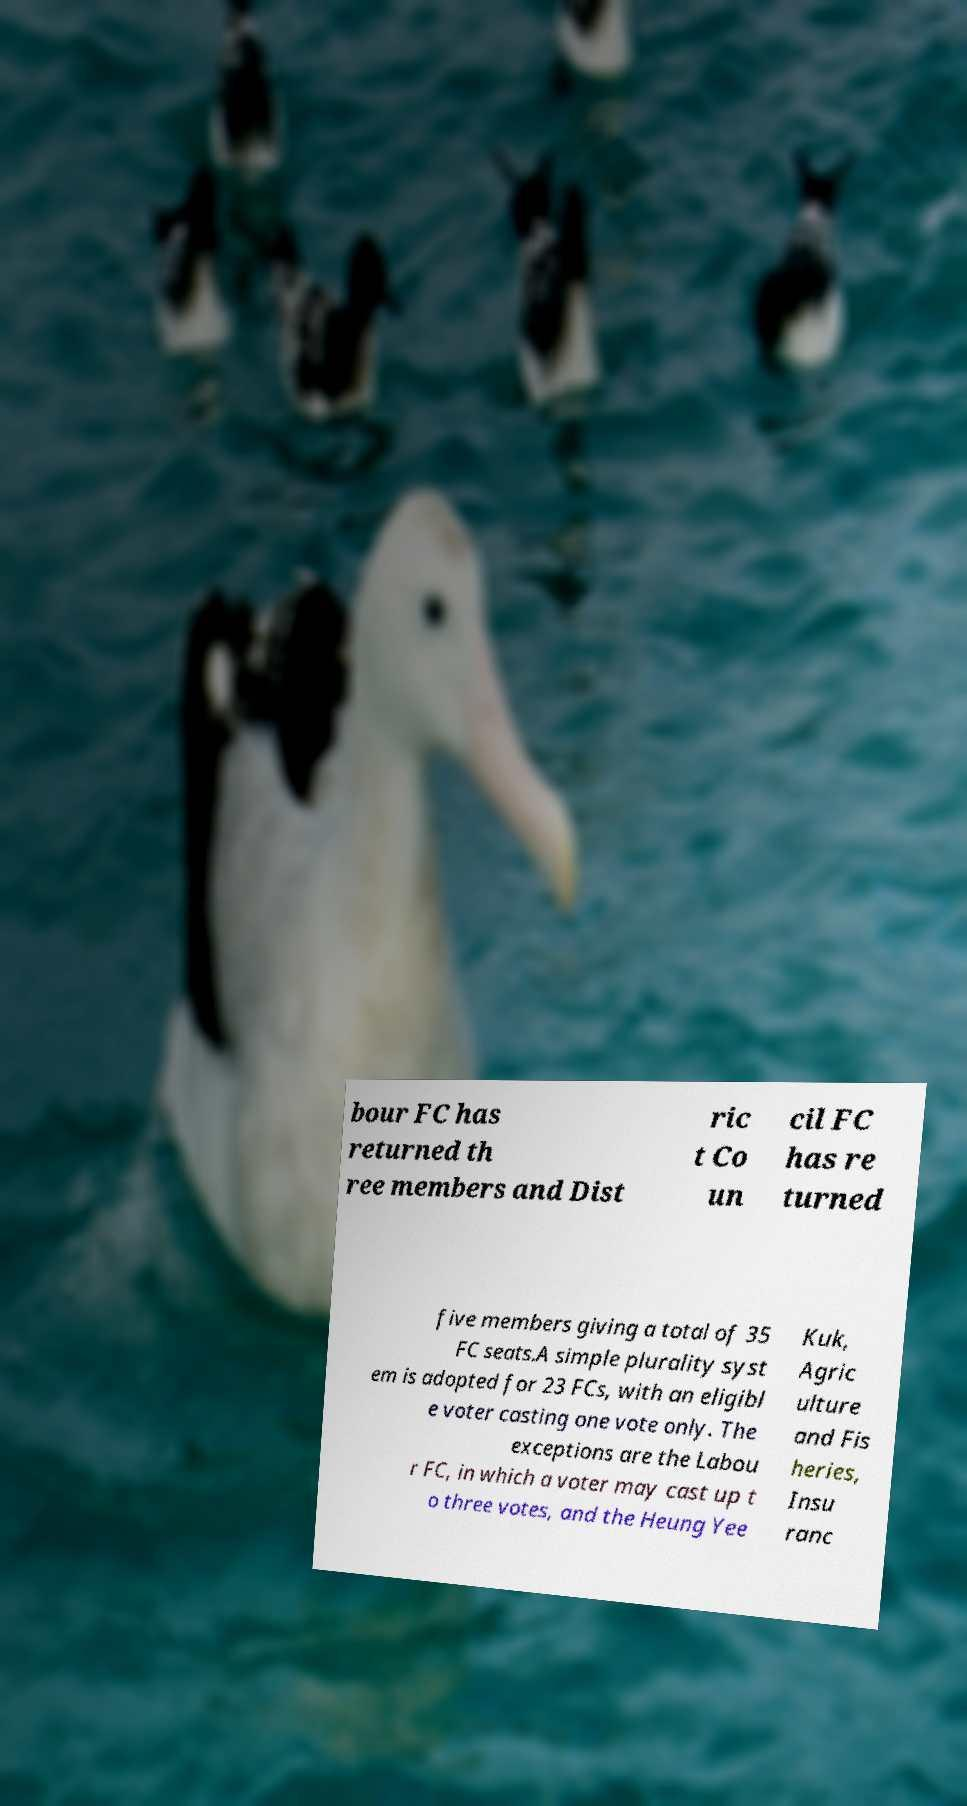Please read and relay the text visible in this image. What does it say? bour FC has returned th ree members and Dist ric t Co un cil FC has re turned five members giving a total of 35 FC seats.A simple plurality syst em is adopted for 23 FCs, with an eligibl e voter casting one vote only. The exceptions are the Labou r FC, in which a voter may cast up t o three votes, and the Heung Yee Kuk, Agric ulture and Fis heries, Insu ranc 